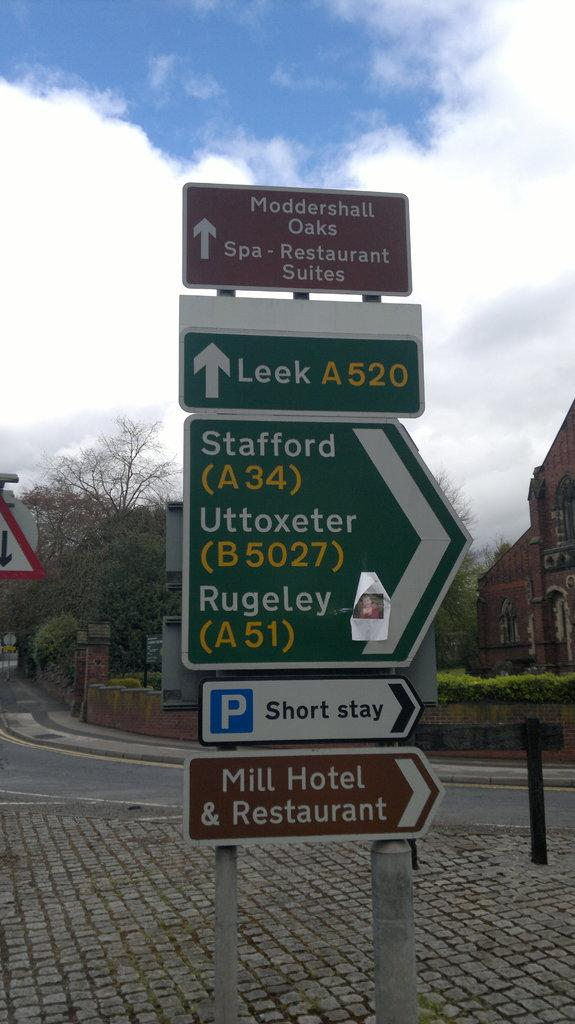What can be seen on the signage boards in the image? The information on the signage boards is not visible in the image, but we can see that there are signage boards present. What type of path is visible in the image? There is a footpath in the image. What type of transportation route is visible in the image? There is a road in the image. What type of vegetation is present in the image? There are trees in the image. What type of residential structures are visible in the image? There are houses in the image. What is the condition of the sky in the image? The sky is clear in the image. What type of celery is growing on the side of the road in the image? There is no celery present in the image; it features signage boards, a footpath, a road, trees, houses, and a clear sky. 